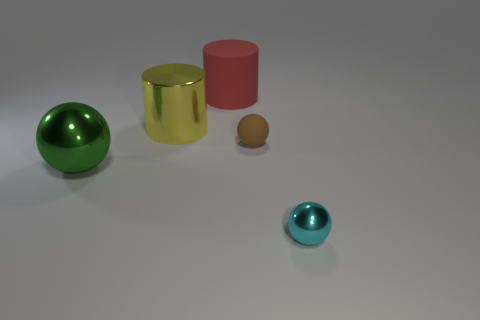Subtract all tiny metal spheres. How many spheres are left? 2 Subtract 1 spheres. How many spheres are left? 2 Add 4 large cyan spheres. How many objects exist? 9 Subtract all cylinders. How many objects are left? 3 Subtract all yellow spheres. Subtract all brown cylinders. How many spheres are left? 3 Add 3 large metallic balls. How many large metallic balls are left? 4 Add 5 tiny metal objects. How many tiny metal objects exist? 6 Subtract 0 cyan blocks. How many objects are left? 5 Subtract all large brown cylinders. Subtract all small things. How many objects are left? 3 